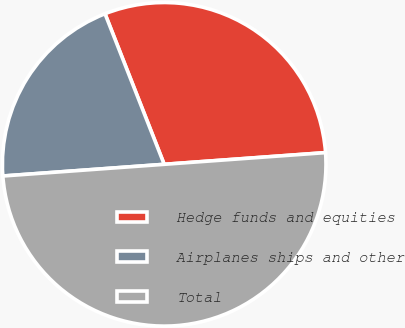<chart> <loc_0><loc_0><loc_500><loc_500><pie_chart><fcel>Hedge funds and equities<fcel>Airplanes ships and other<fcel>Total<nl><fcel>29.81%<fcel>20.19%<fcel>50.0%<nl></chart> 